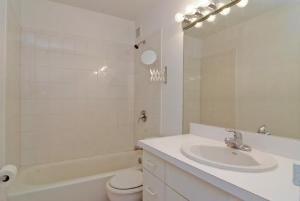How many people are in the water?
Give a very brief answer. 0. 